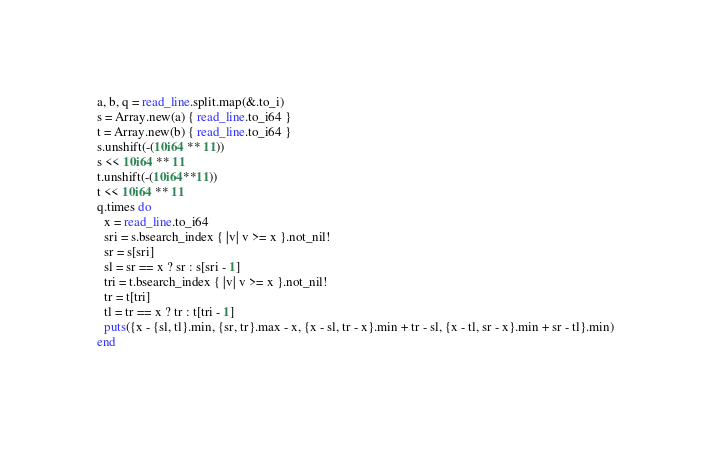<code> <loc_0><loc_0><loc_500><loc_500><_Crystal_>a, b, q = read_line.split.map(&.to_i)
s = Array.new(a) { read_line.to_i64 }
t = Array.new(b) { read_line.to_i64 }
s.unshift(-(10i64 ** 11))
s << 10i64 ** 11
t.unshift(-(10i64**11))
t << 10i64 ** 11
q.times do
  x = read_line.to_i64
  sri = s.bsearch_index { |v| v >= x }.not_nil!
  sr = s[sri]
  sl = sr == x ? sr : s[sri - 1]
  tri = t.bsearch_index { |v| v >= x }.not_nil!
  tr = t[tri]
  tl = tr == x ? tr : t[tri - 1]
  puts({x - {sl, tl}.min, {sr, tr}.max - x, {x - sl, tr - x}.min + tr - sl, {x - tl, sr - x}.min + sr - tl}.min)
end
</code> 